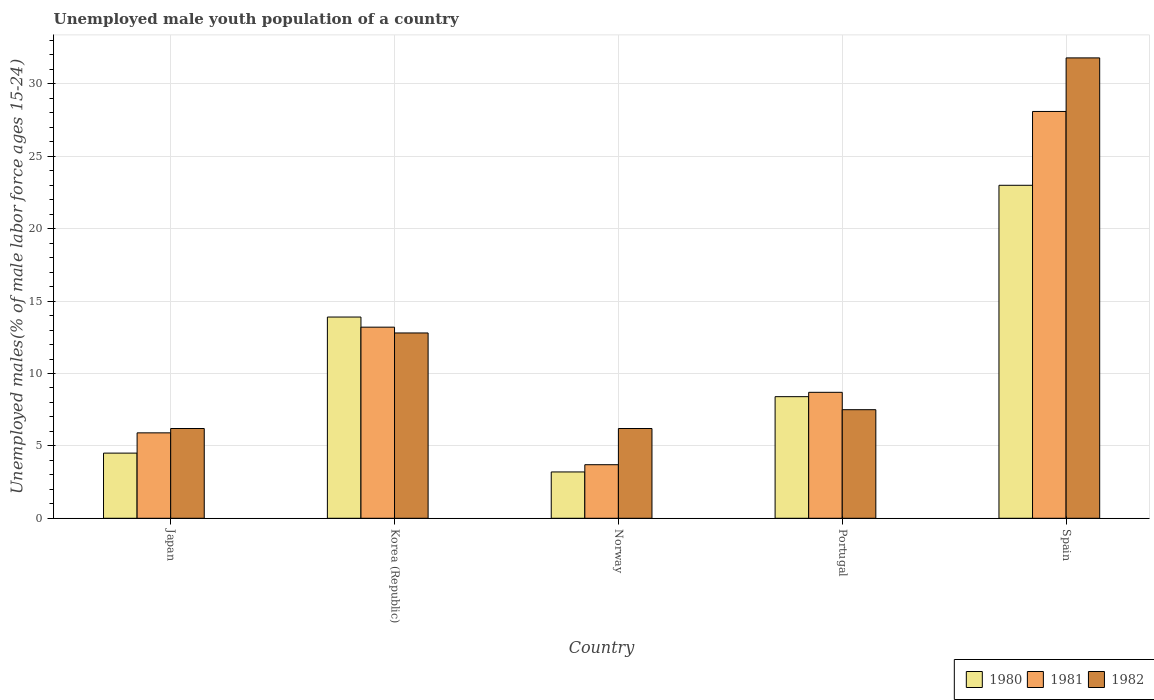How many different coloured bars are there?
Keep it short and to the point. 3. How many groups of bars are there?
Your response must be concise. 5. Are the number of bars per tick equal to the number of legend labels?
Make the answer very short. Yes. How many bars are there on the 4th tick from the right?
Offer a very short reply. 3. What is the label of the 5th group of bars from the left?
Your response must be concise. Spain. In how many cases, is the number of bars for a given country not equal to the number of legend labels?
Provide a short and direct response. 0. What is the percentage of unemployed male youth population in 1982 in Korea (Republic)?
Your answer should be compact. 12.8. Across all countries, what is the maximum percentage of unemployed male youth population in 1982?
Your answer should be very brief. 31.8. Across all countries, what is the minimum percentage of unemployed male youth population in 1981?
Your answer should be compact. 3.7. In which country was the percentage of unemployed male youth population in 1981 maximum?
Provide a succinct answer. Spain. In which country was the percentage of unemployed male youth population in 1980 minimum?
Give a very brief answer. Norway. What is the total percentage of unemployed male youth population in 1980 in the graph?
Your response must be concise. 53. What is the difference between the percentage of unemployed male youth population in 1982 in Japan and that in Korea (Republic)?
Provide a short and direct response. -6.6. What is the average percentage of unemployed male youth population in 1982 per country?
Offer a terse response. 12.9. What is the difference between the percentage of unemployed male youth population of/in 1982 and percentage of unemployed male youth population of/in 1981 in Korea (Republic)?
Your answer should be compact. -0.4. What is the ratio of the percentage of unemployed male youth population in 1981 in Japan to that in Portugal?
Offer a very short reply. 0.68. Is the percentage of unemployed male youth population in 1981 in Japan less than that in Spain?
Give a very brief answer. Yes. What is the difference between the highest and the second highest percentage of unemployed male youth population in 1981?
Keep it short and to the point. -19.4. What is the difference between the highest and the lowest percentage of unemployed male youth population in 1980?
Provide a succinct answer. 19.8. Is the sum of the percentage of unemployed male youth population in 1981 in Portugal and Spain greater than the maximum percentage of unemployed male youth population in 1982 across all countries?
Offer a terse response. Yes. What does the 2nd bar from the right in Japan represents?
Provide a short and direct response. 1981. Is it the case that in every country, the sum of the percentage of unemployed male youth population in 1981 and percentage of unemployed male youth population in 1982 is greater than the percentage of unemployed male youth population in 1980?
Give a very brief answer. Yes. Are all the bars in the graph horizontal?
Provide a short and direct response. No. How many countries are there in the graph?
Make the answer very short. 5. Are the values on the major ticks of Y-axis written in scientific E-notation?
Provide a succinct answer. No. Does the graph contain any zero values?
Make the answer very short. No. Where does the legend appear in the graph?
Offer a terse response. Bottom right. What is the title of the graph?
Offer a terse response. Unemployed male youth population of a country. Does "1969" appear as one of the legend labels in the graph?
Offer a very short reply. No. What is the label or title of the Y-axis?
Provide a succinct answer. Unemployed males(% of male labor force ages 15-24). What is the Unemployed males(% of male labor force ages 15-24) in 1980 in Japan?
Provide a succinct answer. 4.5. What is the Unemployed males(% of male labor force ages 15-24) of 1981 in Japan?
Your response must be concise. 5.9. What is the Unemployed males(% of male labor force ages 15-24) of 1982 in Japan?
Keep it short and to the point. 6.2. What is the Unemployed males(% of male labor force ages 15-24) in 1980 in Korea (Republic)?
Ensure brevity in your answer.  13.9. What is the Unemployed males(% of male labor force ages 15-24) of 1981 in Korea (Republic)?
Keep it short and to the point. 13.2. What is the Unemployed males(% of male labor force ages 15-24) in 1982 in Korea (Republic)?
Ensure brevity in your answer.  12.8. What is the Unemployed males(% of male labor force ages 15-24) in 1980 in Norway?
Offer a terse response. 3.2. What is the Unemployed males(% of male labor force ages 15-24) of 1981 in Norway?
Keep it short and to the point. 3.7. What is the Unemployed males(% of male labor force ages 15-24) of 1982 in Norway?
Offer a very short reply. 6.2. What is the Unemployed males(% of male labor force ages 15-24) in 1980 in Portugal?
Provide a succinct answer. 8.4. What is the Unemployed males(% of male labor force ages 15-24) in 1981 in Portugal?
Your answer should be very brief. 8.7. What is the Unemployed males(% of male labor force ages 15-24) of 1980 in Spain?
Provide a succinct answer. 23. What is the Unemployed males(% of male labor force ages 15-24) in 1981 in Spain?
Make the answer very short. 28.1. What is the Unemployed males(% of male labor force ages 15-24) in 1982 in Spain?
Make the answer very short. 31.8. Across all countries, what is the maximum Unemployed males(% of male labor force ages 15-24) of 1980?
Provide a short and direct response. 23. Across all countries, what is the maximum Unemployed males(% of male labor force ages 15-24) in 1981?
Your response must be concise. 28.1. Across all countries, what is the maximum Unemployed males(% of male labor force ages 15-24) in 1982?
Ensure brevity in your answer.  31.8. Across all countries, what is the minimum Unemployed males(% of male labor force ages 15-24) in 1980?
Your answer should be compact. 3.2. Across all countries, what is the minimum Unemployed males(% of male labor force ages 15-24) in 1981?
Give a very brief answer. 3.7. Across all countries, what is the minimum Unemployed males(% of male labor force ages 15-24) of 1982?
Your response must be concise. 6.2. What is the total Unemployed males(% of male labor force ages 15-24) in 1981 in the graph?
Provide a succinct answer. 59.6. What is the total Unemployed males(% of male labor force ages 15-24) in 1982 in the graph?
Offer a terse response. 64.5. What is the difference between the Unemployed males(% of male labor force ages 15-24) in 1980 in Japan and that in Norway?
Offer a very short reply. 1.3. What is the difference between the Unemployed males(% of male labor force ages 15-24) of 1982 in Japan and that in Norway?
Ensure brevity in your answer.  0. What is the difference between the Unemployed males(% of male labor force ages 15-24) in 1980 in Japan and that in Portugal?
Provide a short and direct response. -3.9. What is the difference between the Unemployed males(% of male labor force ages 15-24) of 1982 in Japan and that in Portugal?
Offer a very short reply. -1.3. What is the difference between the Unemployed males(% of male labor force ages 15-24) in 1980 in Japan and that in Spain?
Your response must be concise. -18.5. What is the difference between the Unemployed males(% of male labor force ages 15-24) in 1981 in Japan and that in Spain?
Provide a succinct answer. -22.2. What is the difference between the Unemployed males(% of male labor force ages 15-24) in 1982 in Japan and that in Spain?
Ensure brevity in your answer.  -25.6. What is the difference between the Unemployed males(% of male labor force ages 15-24) of 1980 in Korea (Republic) and that in Norway?
Provide a short and direct response. 10.7. What is the difference between the Unemployed males(% of male labor force ages 15-24) in 1981 in Korea (Republic) and that in Portugal?
Provide a short and direct response. 4.5. What is the difference between the Unemployed males(% of male labor force ages 15-24) in 1982 in Korea (Republic) and that in Portugal?
Offer a very short reply. 5.3. What is the difference between the Unemployed males(% of male labor force ages 15-24) in 1981 in Korea (Republic) and that in Spain?
Give a very brief answer. -14.9. What is the difference between the Unemployed males(% of male labor force ages 15-24) in 1982 in Korea (Republic) and that in Spain?
Give a very brief answer. -19. What is the difference between the Unemployed males(% of male labor force ages 15-24) of 1980 in Norway and that in Portugal?
Your answer should be compact. -5.2. What is the difference between the Unemployed males(% of male labor force ages 15-24) in 1981 in Norway and that in Portugal?
Your answer should be compact. -5. What is the difference between the Unemployed males(% of male labor force ages 15-24) of 1982 in Norway and that in Portugal?
Provide a short and direct response. -1.3. What is the difference between the Unemployed males(% of male labor force ages 15-24) in 1980 in Norway and that in Spain?
Keep it short and to the point. -19.8. What is the difference between the Unemployed males(% of male labor force ages 15-24) in 1981 in Norway and that in Spain?
Your response must be concise. -24.4. What is the difference between the Unemployed males(% of male labor force ages 15-24) in 1982 in Norway and that in Spain?
Offer a terse response. -25.6. What is the difference between the Unemployed males(% of male labor force ages 15-24) in 1980 in Portugal and that in Spain?
Give a very brief answer. -14.6. What is the difference between the Unemployed males(% of male labor force ages 15-24) in 1981 in Portugal and that in Spain?
Provide a short and direct response. -19.4. What is the difference between the Unemployed males(% of male labor force ages 15-24) in 1982 in Portugal and that in Spain?
Ensure brevity in your answer.  -24.3. What is the difference between the Unemployed males(% of male labor force ages 15-24) of 1980 in Japan and the Unemployed males(% of male labor force ages 15-24) of 1981 in Korea (Republic)?
Ensure brevity in your answer.  -8.7. What is the difference between the Unemployed males(% of male labor force ages 15-24) in 1980 in Japan and the Unemployed males(% of male labor force ages 15-24) in 1982 in Korea (Republic)?
Offer a terse response. -8.3. What is the difference between the Unemployed males(% of male labor force ages 15-24) in 1981 in Japan and the Unemployed males(% of male labor force ages 15-24) in 1982 in Korea (Republic)?
Provide a succinct answer. -6.9. What is the difference between the Unemployed males(% of male labor force ages 15-24) in 1980 in Japan and the Unemployed males(% of male labor force ages 15-24) in 1981 in Portugal?
Your response must be concise. -4.2. What is the difference between the Unemployed males(% of male labor force ages 15-24) in 1981 in Japan and the Unemployed males(% of male labor force ages 15-24) in 1982 in Portugal?
Offer a very short reply. -1.6. What is the difference between the Unemployed males(% of male labor force ages 15-24) in 1980 in Japan and the Unemployed males(% of male labor force ages 15-24) in 1981 in Spain?
Your response must be concise. -23.6. What is the difference between the Unemployed males(% of male labor force ages 15-24) in 1980 in Japan and the Unemployed males(% of male labor force ages 15-24) in 1982 in Spain?
Your response must be concise. -27.3. What is the difference between the Unemployed males(% of male labor force ages 15-24) in 1981 in Japan and the Unemployed males(% of male labor force ages 15-24) in 1982 in Spain?
Make the answer very short. -25.9. What is the difference between the Unemployed males(% of male labor force ages 15-24) in 1980 in Korea (Republic) and the Unemployed males(% of male labor force ages 15-24) in 1981 in Norway?
Keep it short and to the point. 10.2. What is the difference between the Unemployed males(% of male labor force ages 15-24) of 1980 in Korea (Republic) and the Unemployed males(% of male labor force ages 15-24) of 1982 in Portugal?
Keep it short and to the point. 6.4. What is the difference between the Unemployed males(% of male labor force ages 15-24) in 1981 in Korea (Republic) and the Unemployed males(% of male labor force ages 15-24) in 1982 in Portugal?
Offer a terse response. 5.7. What is the difference between the Unemployed males(% of male labor force ages 15-24) of 1980 in Korea (Republic) and the Unemployed males(% of male labor force ages 15-24) of 1982 in Spain?
Your answer should be compact. -17.9. What is the difference between the Unemployed males(% of male labor force ages 15-24) of 1981 in Korea (Republic) and the Unemployed males(% of male labor force ages 15-24) of 1982 in Spain?
Provide a succinct answer. -18.6. What is the difference between the Unemployed males(% of male labor force ages 15-24) in 1981 in Norway and the Unemployed males(% of male labor force ages 15-24) in 1982 in Portugal?
Provide a short and direct response. -3.8. What is the difference between the Unemployed males(% of male labor force ages 15-24) of 1980 in Norway and the Unemployed males(% of male labor force ages 15-24) of 1981 in Spain?
Provide a succinct answer. -24.9. What is the difference between the Unemployed males(% of male labor force ages 15-24) of 1980 in Norway and the Unemployed males(% of male labor force ages 15-24) of 1982 in Spain?
Your answer should be very brief. -28.6. What is the difference between the Unemployed males(% of male labor force ages 15-24) in 1981 in Norway and the Unemployed males(% of male labor force ages 15-24) in 1982 in Spain?
Offer a very short reply. -28.1. What is the difference between the Unemployed males(% of male labor force ages 15-24) in 1980 in Portugal and the Unemployed males(% of male labor force ages 15-24) in 1981 in Spain?
Provide a short and direct response. -19.7. What is the difference between the Unemployed males(% of male labor force ages 15-24) in 1980 in Portugal and the Unemployed males(% of male labor force ages 15-24) in 1982 in Spain?
Your response must be concise. -23.4. What is the difference between the Unemployed males(% of male labor force ages 15-24) of 1981 in Portugal and the Unemployed males(% of male labor force ages 15-24) of 1982 in Spain?
Your answer should be compact. -23.1. What is the average Unemployed males(% of male labor force ages 15-24) in 1981 per country?
Provide a succinct answer. 11.92. What is the average Unemployed males(% of male labor force ages 15-24) of 1982 per country?
Give a very brief answer. 12.9. What is the difference between the Unemployed males(% of male labor force ages 15-24) of 1980 and Unemployed males(% of male labor force ages 15-24) of 1981 in Japan?
Your answer should be very brief. -1.4. What is the difference between the Unemployed males(% of male labor force ages 15-24) of 1980 and Unemployed males(% of male labor force ages 15-24) of 1982 in Korea (Republic)?
Ensure brevity in your answer.  1.1. What is the difference between the Unemployed males(% of male labor force ages 15-24) in 1981 and Unemployed males(% of male labor force ages 15-24) in 1982 in Korea (Republic)?
Offer a very short reply. 0.4. What is the difference between the Unemployed males(% of male labor force ages 15-24) of 1980 and Unemployed males(% of male labor force ages 15-24) of 1981 in Norway?
Provide a succinct answer. -0.5. What is the difference between the Unemployed males(% of male labor force ages 15-24) of 1980 and Unemployed males(% of male labor force ages 15-24) of 1982 in Norway?
Give a very brief answer. -3. What is the difference between the Unemployed males(% of male labor force ages 15-24) in 1980 and Unemployed males(% of male labor force ages 15-24) in 1981 in Portugal?
Make the answer very short. -0.3. What is the difference between the Unemployed males(% of male labor force ages 15-24) of 1980 and Unemployed males(% of male labor force ages 15-24) of 1982 in Portugal?
Provide a succinct answer. 0.9. What is the difference between the Unemployed males(% of male labor force ages 15-24) of 1980 and Unemployed males(% of male labor force ages 15-24) of 1982 in Spain?
Provide a succinct answer. -8.8. What is the difference between the Unemployed males(% of male labor force ages 15-24) of 1981 and Unemployed males(% of male labor force ages 15-24) of 1982 in Spain?
Make the answer very short. -3.7. What is the ratio of the Unemployed males(% of male labor force ages 15-24) in 1980 in Japan to that in Korea (Republic)?
Offer a very short reply. 0.32. What is the ratio of the Unemployed males(% of male labor force ages 15-24) in 1981 in Japan to that in Korea (Republic)?
Make the answer very short. 0.45. What is the ratio of the Unemployed males(% of male labor force ages 15-24) in 1982 in Japan to that in Korea (Republic)?
Offer a terse response. 0.48. What is the ratio of the Unemployed males(% of male labor force ages 15-24) of 1980 in Japan to that in Norway?
Offer a very short reply. 1.41. What is the ratio of the Unemployed males(% of male labor force ages 15-24) of 1981 in Japan to that in Norway?
Provide a short and direct response. 1.59. What is the ratio of the Unemployed males(% of male labor force ages 15-24) of 1980 in Japan to that in Portugal?
Offer a very short reply. 0.54. What is the ratio of the Unemployed males(% of male labor force ages 15-24) in 1981 in Japan to that in Portugal?
Offer a very short reply. 0.68. What is the ratio of the Unemployed males(% of male labor force ages 15-24) of 1982 in Japan to that in Portugal?
Make the answer very short. 0.83. What is the ratio of the Unemployed males(% of male labor force ages 15-24) of 1980 in Japan to that in Spain?
Provide a short and direct response. 0.2. What is the ratio of the Unemployed males(% of male labor force ages 15-24) of 1981 in Japan to that in Spain?
Keep it short and to the point. 0.21. What is the ratio of the Unemployed males(% of male labor force ages 15-24) of 1982 in Japan to that in Spain?
Your response must be concise. 0.2. What is the ratio of the Unemployed males(% of male labor force ages 15-24) in 1980 in Korea (Republic) to that in Norway?
Provide a short and direct response. 4.34. What is the ratio of the Unemployed males(% of male labor force ages 15-24) of 1981 in Korea (Republic) to that in Norway?
Ensure brevity in your answer.  3.57. What is the ratio of the Unemployed males(% of male labor force ages 15-24) in 1982 in Korea (Republic) to that in Norway?
Make the answer very short. 2.06. What is the ratio of the Unemployed males(% of male labor force ages 15-24) of 1980 in Korea (Republic) to that in Portugal?
Give a very brief answer. 1.65. What is the ratio of the Unemployed males(% of male labor force ages 15-24) in 1981 in Korea (Republic) to that in Portugal?
Ensure brevity in your answer.  1.52. What is the ratio of the Unemployed males(% of male labor force ages 15-24) of 1982 in Korea (Republic) to that in Portugal?
Provide a succinct answer. 1.71. What is the ratio of the Unemployed males(% of male labor force ages 15-24) in 1980 in Korea (Republic) to that in Spain?
Ensure brevity in your answer.  0.6. What is the ratio of the Unemployed males(% of male labor force ages 15-24) of 1981 in Korea (Republic) to that in Spain?
Offer a terse response. 0.47. What is the ratio of the Unemployed males(% of male labor force ages 15-24) in 1982 in Korea (Republic) to that in Spain?
Provide a short and direct response. 0.4. What is the ratio of the Unemployed males(% of male labor force ages 15-24) in 1980 in Norway to that in Portugal?
Your response must be concise. 0.38. What is the ratio of the Unemployed males(% of male labor force ages 15-24) in 1981 in Norway to that in Portugal?
Provide a succinct answer. 0.43. What is the ratio of the Unemployed males(% of male labor force ages 15-24) of 1982 in Norway to that in Portugal?
Give a very brief answer. 0.83. What is the ratio of the Unemployed males(% of male labor force ages 15-24) of 1980 in Norway to that in Spain?
Offer a very short reply. 0.14. What is the ratio of the Unemployed males(% of male labor force ages 15-24) of 1981 in Norway to that in Spain?
Your answer should be very brief. 0.13. What is the ratio of the Unemployed males(% of male labor force ages 15-24) of 1982 in Norway to that in Spain?
Make the answer very short. 0.2. What is the ratio of the Unemployed males(% of male labor force ages 15-24) in 1980 in Portugal to that in Spain?
Ensure brevity in your answer.  0.37. What is the ratio of the Unemployed males(% of male labor force ages 15-24) in 1981 in Portugal to that in Spain?
Make the answer very short. 0.31. What is the ratio of the Unemployed males(% of male labor force ages 15-24) in 1982 in Portugal to that in Spain?
Ensure brevity in your answer.  0.24. What is the difference between the highest and the second highest Unemployed males(% of male labor force ages 15-24) of 1981?
Make the answer very short. 14.9. What is the difference between the highest and the second highest Unemployed males(% of male labor force ages 15-24) of 1982?
Make the answer very short. 19. What is the difference between the highest and the lowest Unemployed males(% of male labor force ages 15-24) in 1980?
Your answer should be very brief. 19.8. What is the difference between the highest and the lowest Unemployed males(% of male labor force ages 15-24) of 1981?
Keep it short and to the point. 24.4. What is the difference between the highest and the lowest Unemployed males(% of male labor force ages 15-24) of 1982?
Provide a succinct answer. 25.6. 